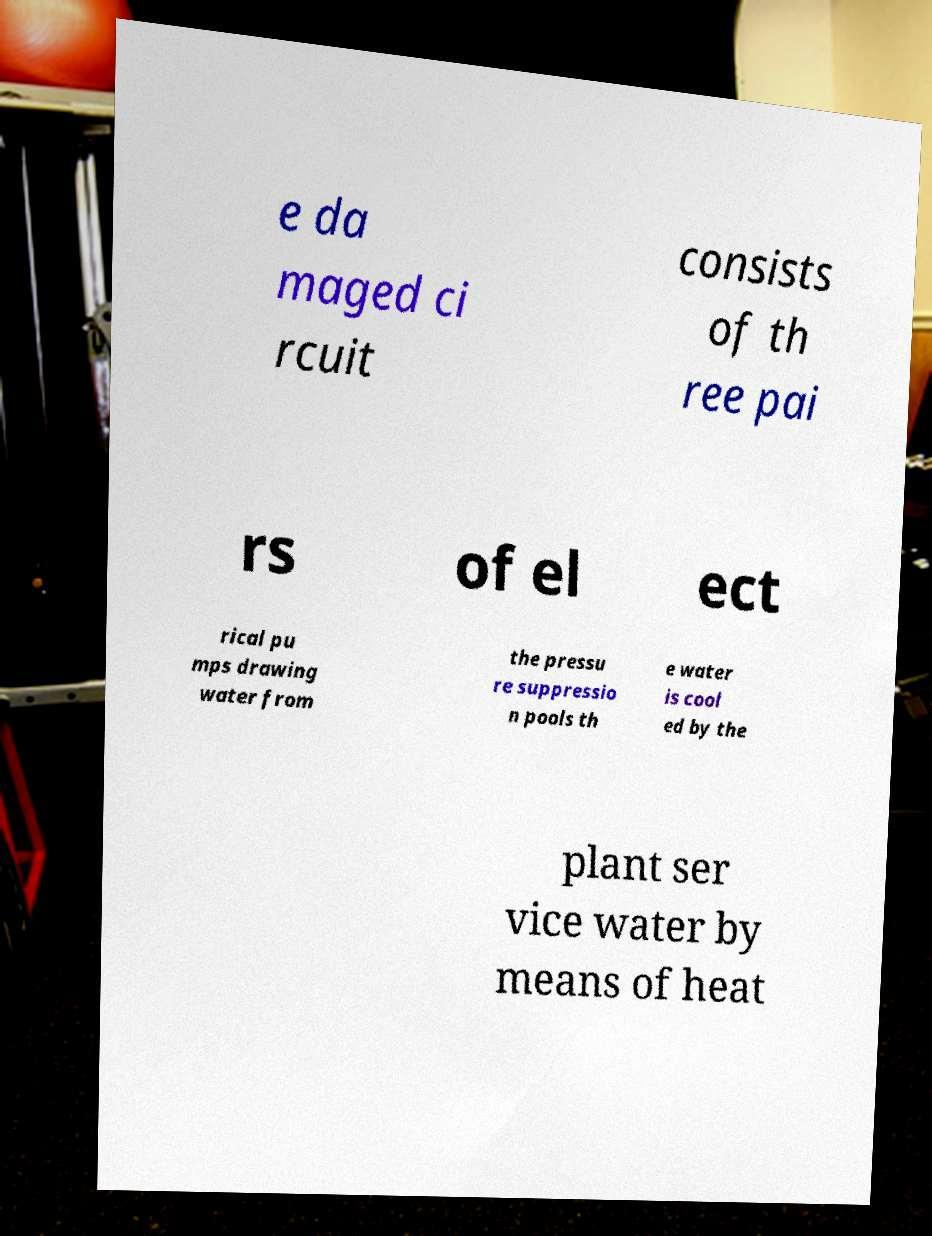There's text embedded in this image that I need extracted. Can you transcribe it verbatim? e da maged ci rcuit consists of th ree pai rs of el ect rical pu mps drawing water from the pressu re suppressio n pools th e water is cool ed by the plant ser vice water by means of heat 